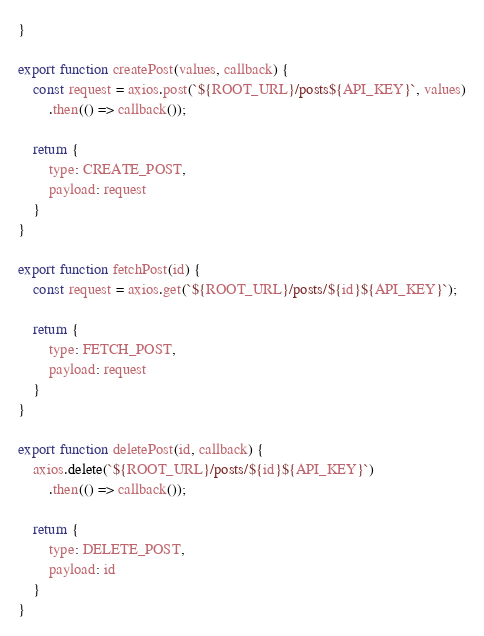Convert code to text. <code><loc_0><loc_0><loc_500><loc_500><_JavaScript_>}

export function createPost(values, callback) {
    const request = axios.post(`${ROOT_URL}/posts${API_KEY}`, values)
        .then(() => callback());

    return {
        type: CREATE_POST,
        payload: request
    }
}

export function fetchPost(id) {
    const request = axios.get(`${ROOT_URL}/posts/${id}${API_KEY}`);

    return {
        type: FETCH_POST,
        payload: request
    }
}

export function deletePost(id, callback) {
    axios.delete(`${ROOT_URL}/posts/${id}${API_KEY}`)
        .then(() => callback());

    return {
        type: DELETE_POST,
        payload: id
    }
}</code> 